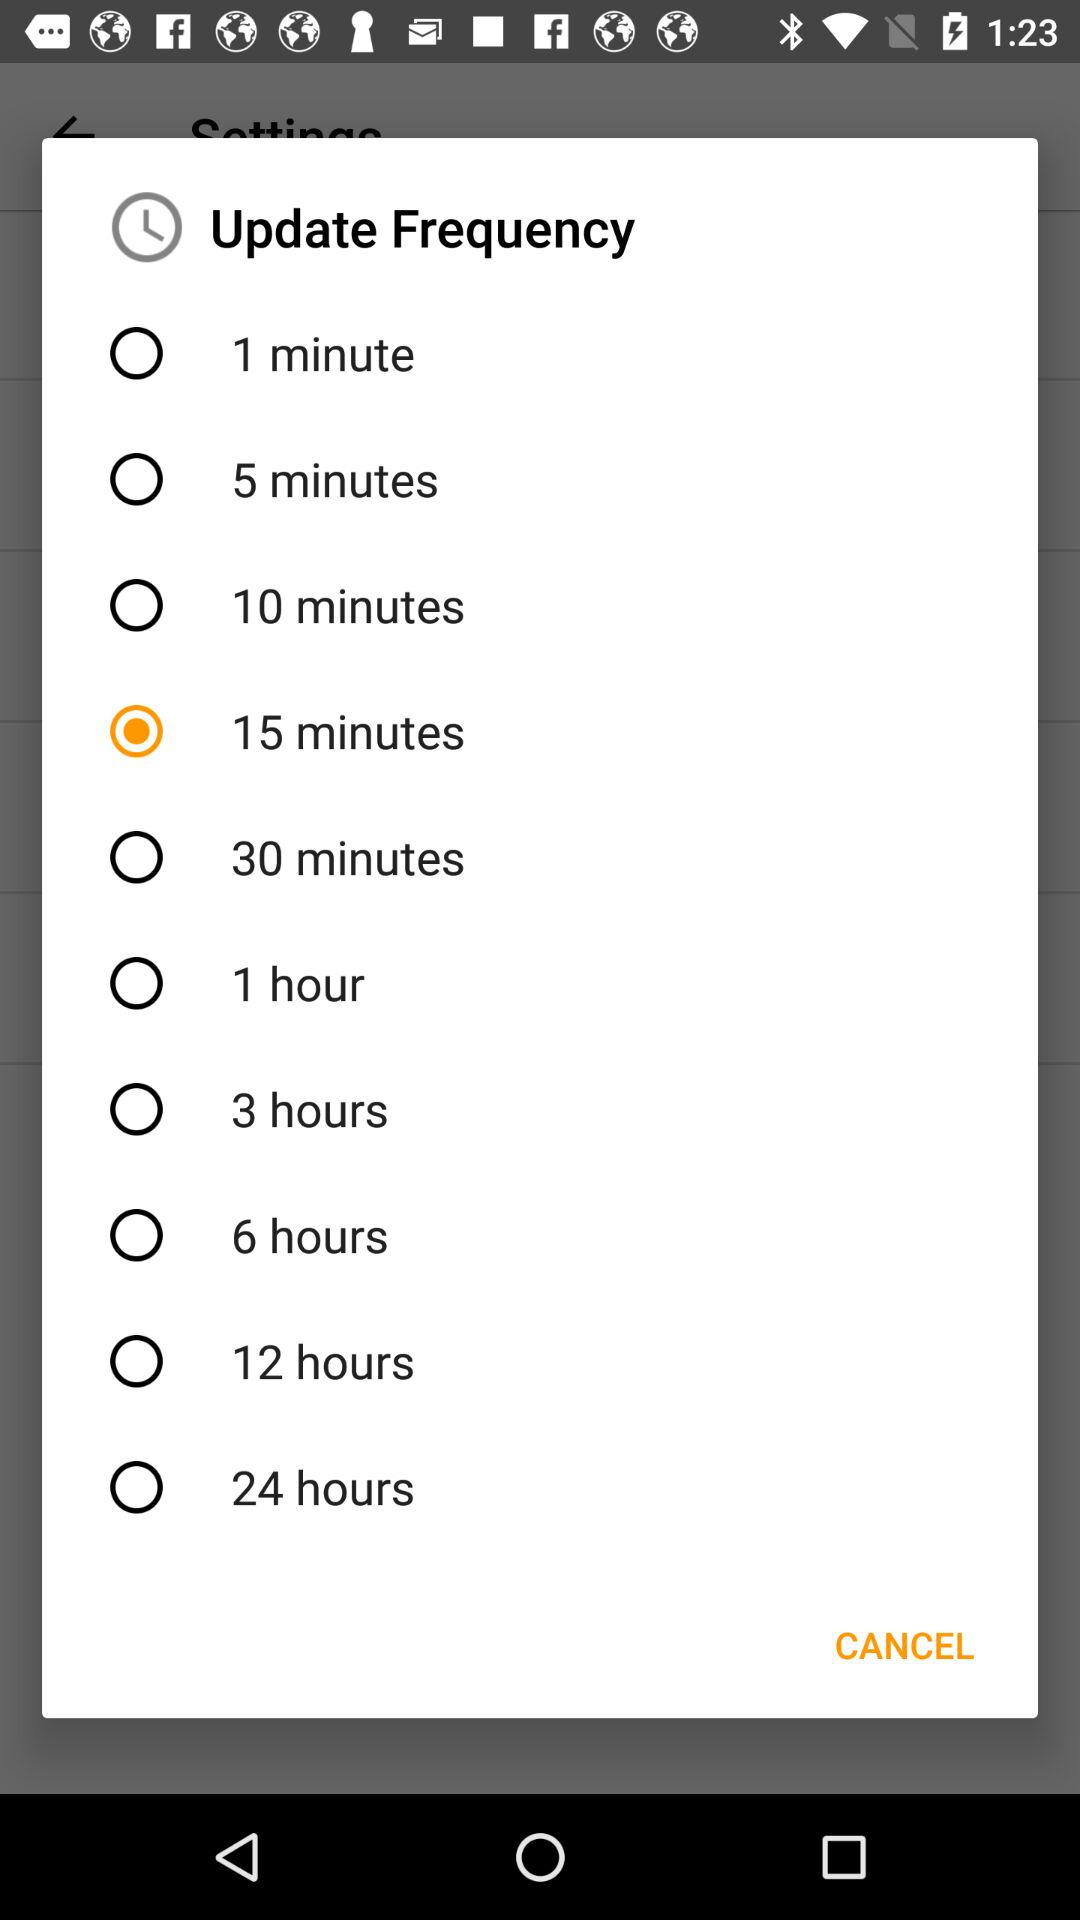How many update frequencies are there?
Answer the question using a single word or phrase. 10 